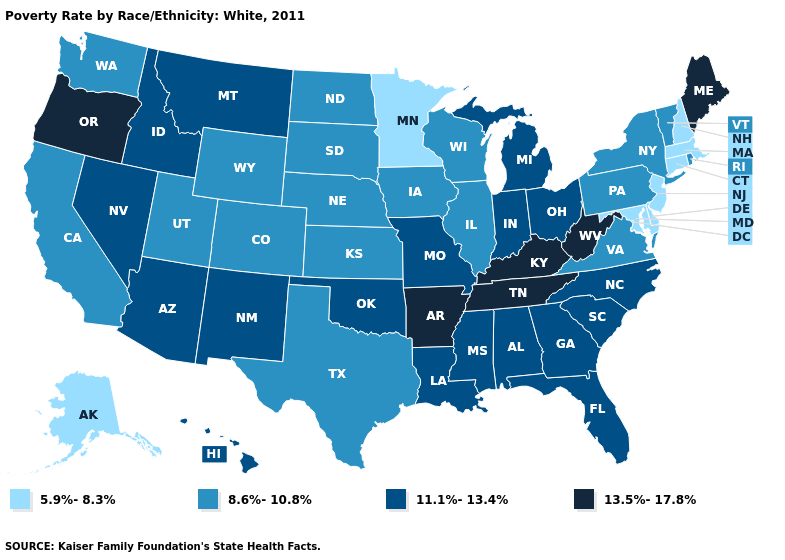Does the first symbol in the legend represent the smallest category?
Write a very short answer. Yes. What is the highest value in the USA?
Answer briefly. 13.5%-17.8%. Name the states that have a value in the range 5.9%-8.3%?
Quick response, please. Alaska, Connecticut, Delaware, Maryland, Massachusetts, Minnesota, New Hampshire, New Jersey. Name the states that have a value in the range 13.5%-17.8%?
Give a very brief answer. Arkansas, Kentucky, Maine, Oregon, Tennessee, West Virginia. What is the highest value in the Northeast ?
Give a very brief answer. 13.5%-17.8%. How many symbols are there in the legend?
Concise answer only. 4. What is the value of Oklahoma?
Concise answer only. 11.1%-13.4%. What is the highest value in the MidWest ?
Quick response, please. 11.1%-13.4%. Which states have the lowest value in the USA?
Write a very short answer. Alaska, Connecticut, Delaware, Maryland, Massachusetts, Minnesota, New Hampshire, New Jersey. What is the value of Alaska?
Quick response, please. 5.9%-8.3%. Among the states that border New Mexico , which have the highest value?
Answer briefly. Arizona, Oklahoma. What is the value of North Carolina?
Be succinct. 11.1%-13.4%. Does the first symbol in the legend represent the smallest category?
Short answer required. Yes. Name the states that have a value in the range 11.1%-13.4%?
Answer briefly. Alabama, Arizona, Florida, Georgia, Hawaii, Idaho, Indiana, Louisiana, Michigan, Mississippi, Missouri, Montana, Nevada, New Mexico, North Carolina, Ohio, Oklahoma, South Carolina. What is the highest value in the USA?
Keep it brief. 13.5%-17.8%. 